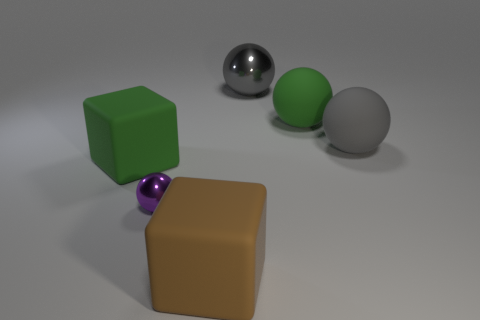Add 3 brown matte cubes. How many objects exist? 9 Subtract all blocks. How many objects are left? 4 Subtract 1 purple spheres. How many objects are left? 5 Subtract all tiny blue blocks. Subtract all large objects. How many objects are left? 1 Add 3 large green matte things. How many large green matte things are left? 5 Add 4 large purple metallic balls. How many large purple metallic balls exist? 4 